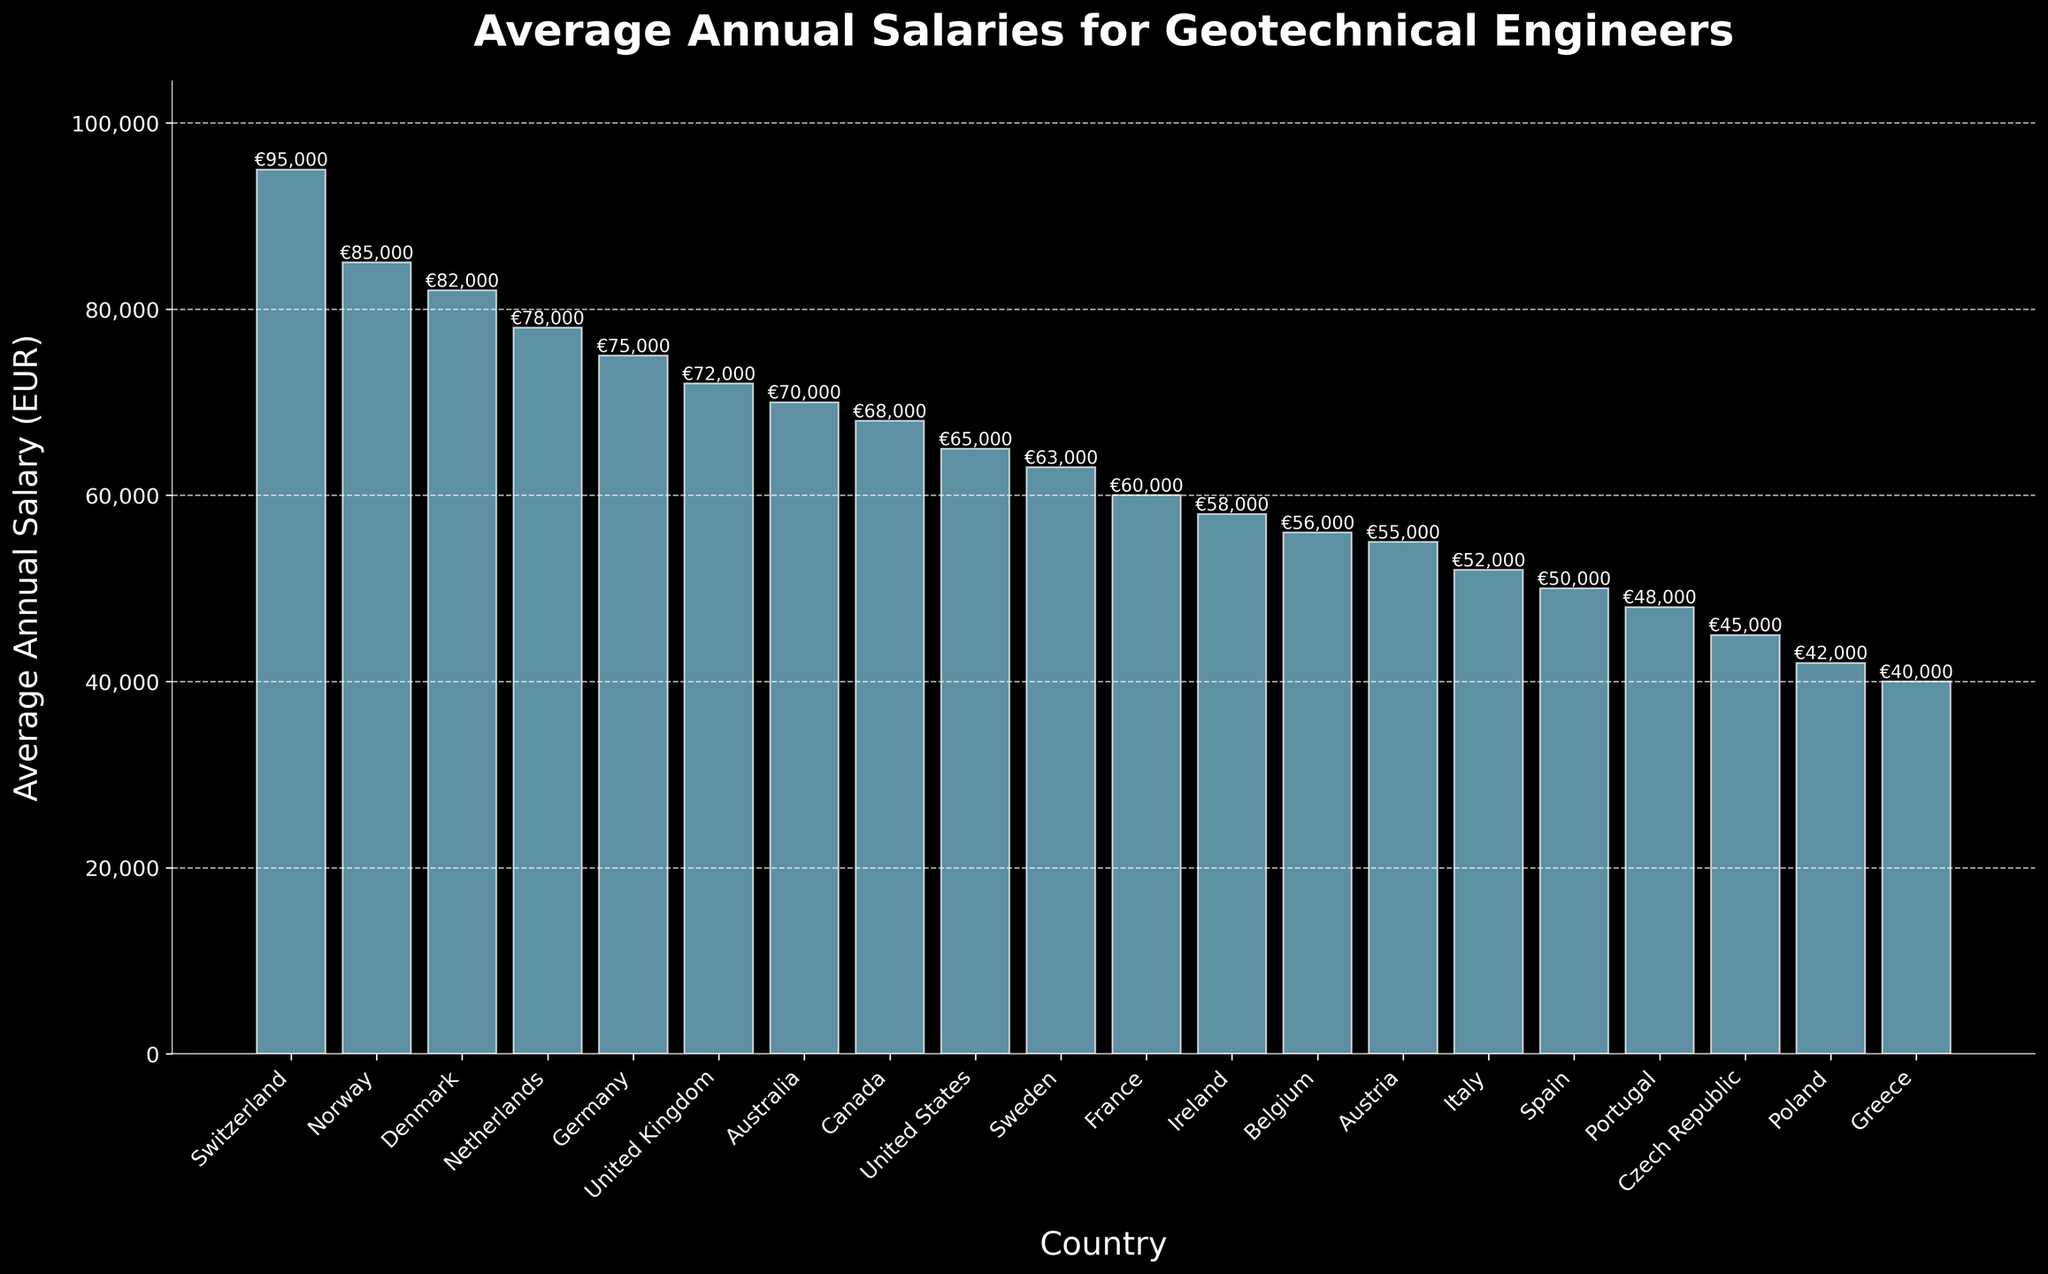Which country has the highest average annual salary for geotechnical engineers? To find which country has the highest average salary, compare the heights of all bars. The tallest bar corresponds to Switzerland.
Answer: Switzerland Which country has the lowest average annual salary for geotechnical engineers? To determine the lowest salary, look for the shortest bar in the chart, which is attributed to Greece.
Answer: Greece How much higher is the average annual salary in Switzerland compared to Germany? Find the salaries for Switzerland (€95,000) and Germany (€75,000). Subtract Germany's salary from Switzerland's: €95,000 - €75,000 = €20,000.
Answer: €20,000 What is the total combined average annual salary for geotechnical engineers in Germany and France? Add the salaries for Germany (€75,000) and France (€60,000): €75,000 + €60,000 = €135,000.
Answer: €135,000 Which three countries have the closest average annual salaries to each other, and what are these values? Locate the countries with similar bar heights. Norway (€85,000), Denmark (€82,000), and the Netherlands (€78,000) are closest in salary.
Answer: Norway, Denmark, Netherlands - €85,000, €82,000, €78,000 What is the average annual salary difference between the United Kingdom and Australia? Subtract Australia's salary (€70,000) from the United Kingdom's salary (€72,000): €72,000 - €70,000 = €2,000.
Answer: €2,000 Between which two countries is there the largest salary gap? Calculate the differences between all countries. The largest gap is between Switzerland (€95,000) and Greece (€40,000): €95,000 - €40,000 = €55,000.
Answer: Switzerland and Greece How does the average annual salary in Belgium compare visually to that in Ireland? Observe the heights of the bars for Belgium (€56,000) and Ireland (€58,000). Belgium's bar is slightly shorter than Ireland's bar.
Answer: Belgium is slightly lower By how much does the average annual salary in Portugal fall short of the average salary in the Netherlands? Subtract Portugal’s salary (€48,000) from the Netherlands' salary (€78,000): €78,000 - €48,000 = €30,000.
Answer: €30,000 What is the range of average annual salaries for geotechnical engineers in the top five countries? The top five countries are Switzerland (€95,000), Norway (€85,000), Denmark (€82,000), Netherlands (€78,000), and Germany (€75,000). The range is the difference between the highest (€95,000) and the lowest (€75,000): €95,000 - €75,000 = €20,000.
Answer: €20,000 